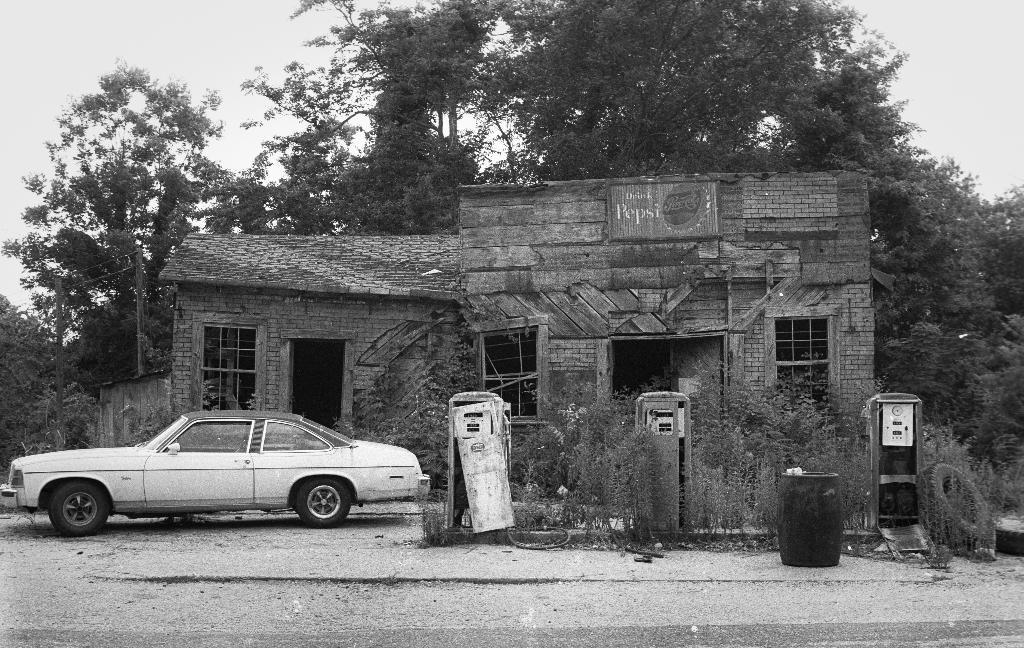What is the main subject of the image? There is a car in the image. What else can be seen near the car? There are machines near the car. Are there any natural elements in the image? Yes, there are plants in the image. What other man-made structures can be seen in the image? There is a dustbin and a house with windows in the image. What is visible in the background of the image? There are many trees and the sky in the background of the image. What type of rod can be seen holding up the bridge in the image? There is no bridge present in the image, so there is no rod holding it up. Can you describe the robin's nest in the image? There is no robin or its nest present in the image. 